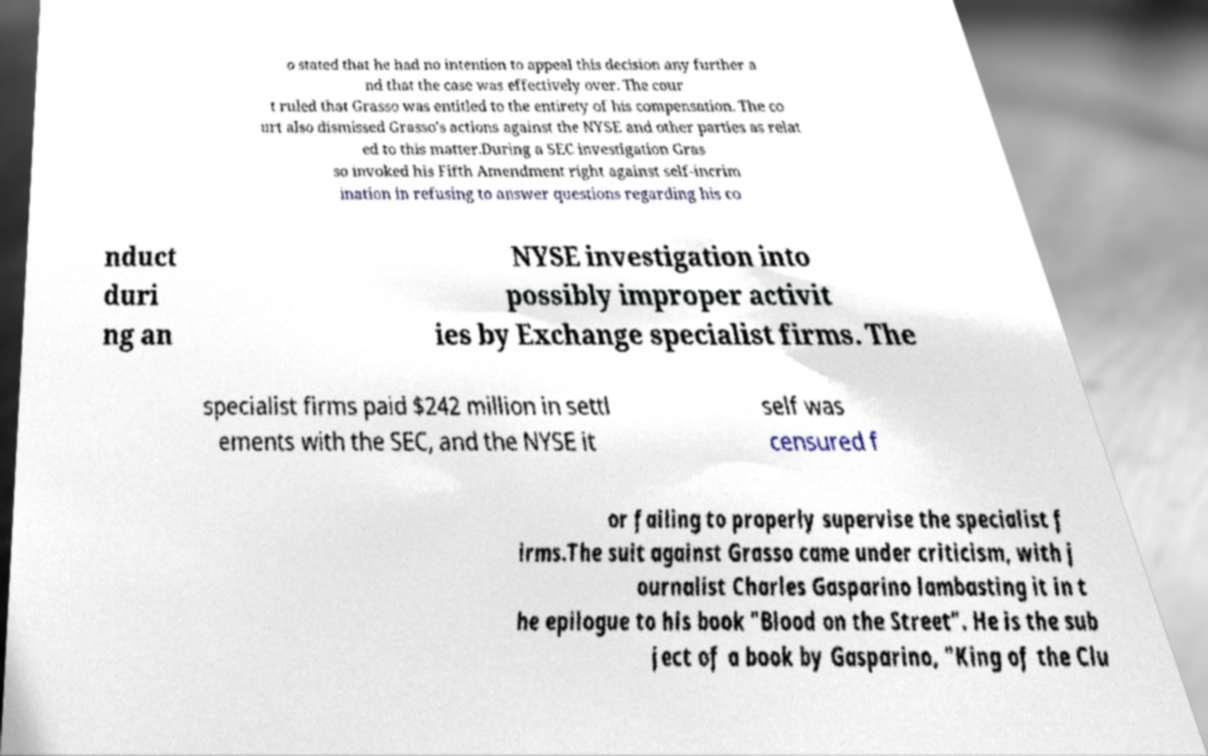For documentation purposes, I need the text within this image transcribed. Could you provide that? o stated that he had no intention to appeal this decision any further a nd that the case was effectively over. The cour t ruled that Grasso was entitled to the entirety of his compensation. The co urt also dismissed Grasso's actions against the NYSE and other parties as relat ed to this matter.During a SEC investigation Gras so invoked his Fifth Amendment right against self-incrim ination in refusing to answer questions regarding his co nduct duri ng an NYSE investigation into possibly improper activit ies by Exchange specialist firms. The specialist firms paid $242 million in settl ements with the SEC, and the NYSE it self was censured f or failing to properly supervise the specialist f irms.The suit against Grasso came under criticism, with j ournalist Charles Gasparino lambasting it in t he epilogue to his book "Blood on the Street". He is the sub ject of a book by Gasparino, "King of the Clu 